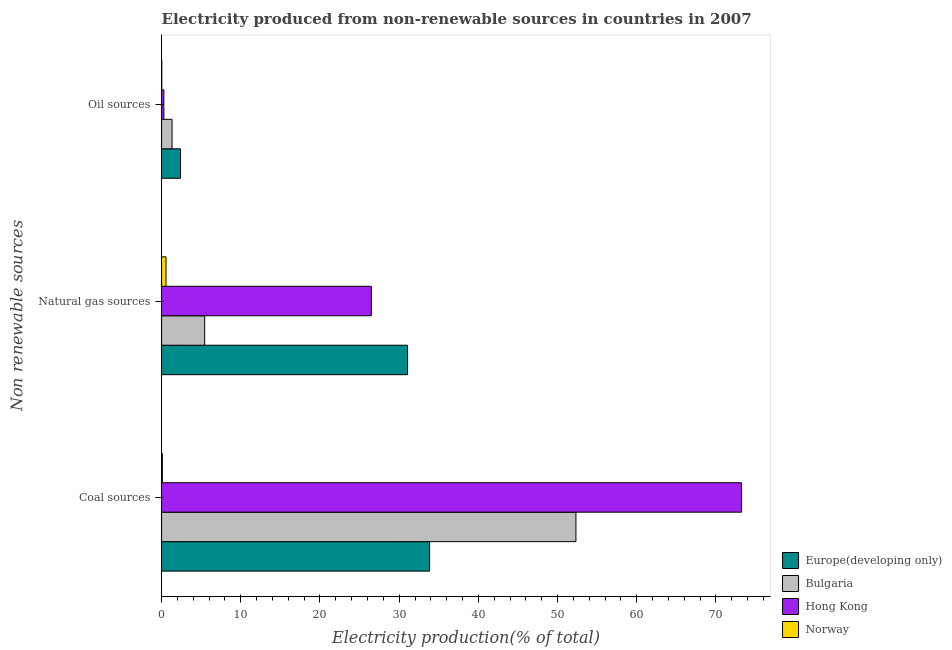Are the number of bars on each tick of the Y-axis equal?
Your answer should be very brief. Yes. What is the label of the 3rd group of bars from the top?
Your response must be concise. Coal sources. What is the percentage of electricity produced by coal in Hong Kong?
Provide a short and direct response. 73.23. Across all countries, what is the maximum percentage of electricity produced by coal?
Provide a short and direct response. 73.23. Across all countries, what is the minimum percentage of electricity produced by oil sources?
Make the answer very short. 0.03. In which country was the percentage of electricity produced by coal maximum?
Offer a terse response. Hong Kong. What is the total percentage of electricity produced by coal in the graph?
Your response must be concise. 159.48. What is the difference between the percentage of electricity produced by coal in Norway and that in Bulgaria?
Make the answer very short. -52.22. What is the difference between the percentage of electricity produced by coal in Europe(developing only) and the percentage of electricity produced by natural gas in Bulgaria?
Offer a terse response. 28.4. What is the average percentage of electricity produced by oil sources per country?
Provide a succinct answer. 1.01. What is the difference between the percentage of electricity produced by coal and percentage of electricity produced by oil sources in Bulgaria?
Offer a terse response. 50.99. In how many countries, is the percentage of electricity produced by oil sources greater than 64 %?
Your answer should be very brief. 0. What is the ratio of the percentage of electricity produced by coal in Norway to that in Bulgaria?
Make the answer very short. 0. Is the percentage of electricity produced by oil sources in Bulgaria less than that in Hong Kong?
Ensure brevity in your answer.  No. What is the difference between the highest and the second highest percentage of electricity produced by coal?
Your response must be concise. 20.91. What is the difference between the highest and the lowest percentage of electricity produced by oil sources?
Offer a very short reply. 2.37. In how many countries, is the percentage of electricity produced by coal greater than the average percentage of electricity produced by coal taken over all countries?
Your answer should be very brief. 2. Is the sum of the percentage of electricity produced by coal in Bulgaria and Norway greater than the maximum percentage of electricity produced by oil sources across all countries?
Keep it short and to the point. Yes. What does the 1st bar from the top in Natural gas sources represents?
Your response must be concise. Norway. What does the 1st bar from the bottom in Coal sources represents?
Keep it short and to the point. Europe(developing only). How many bars are there?
Your response must be concise. 12. What is the difference between two consecutive major ticks on the X-axis?
Your answer should be compact. 10. Are the values on the major ticks of X-axis written in scientific E-notation?
Provide a succinct answer. No. Does the graph contain grids?
Your answer should be compact. No. What is the title of the graph?
Offer a terse response. Electricity produced from non-renewable sources in countries in 2007. What is the label or title of the Y-axis?
Make the answer very short. Non renewable sources. What is the Electricity production(% of total) in Europe(developing only) in Coal sources?
Make the answer very short. 33.84. What is the Electricity production(% of total) in Bulgaria in Coal sources?
Ensure brevity in your answer.  52.32. What is the Electricity production(% of total) in Hong Kong in Coal sources?
Your answer should be very brief. 73.23. What is the Electricity production(% of total) in Norway in Coal sources?
Offer a terse response. 0.1. What is the Electricity production(% of total) of Europe(developing only) in Natural gas sources?
Offer a very short reply. 31.06. What is the Electricity production(% of total) in Bulgaria in Natural gas sources?
Offer a terse response. 5.44. What is the Electricity production(% of total) in Hong Kong in Natural gas sources?
Your response must be concise. 26.48. What is the Electricity production(% of total) of Norway in Natural gas sources?
Your response must be concise. 0.56. What is the Electricity production(% of total) in Europe(developing only) in Oil sources?
Your response must be concise. 2.39. What is the Electricity production(% of total) of Bulgaria in Oil sources?
Offer a very short reply. 1.32. What is the Electricity production(% of total) in Hong Kong in Oil sources?
Give a very brief answer. 0.29. What is the Electricity production(% of total) of Norway in Oil sources?
Keep it short and to the point. 0.03. Across all Non renewable sources, what is the maximum Electricity production(% of total) in Europe(developing only)?
Your answer should be very brief. 33.84. Across all Non renewable sources, what is the maximum Electricity production(% of total) in Bulgaria?
Provide a succinct answer. 52.32. Across all Non renewable sources, what is the maximum Electricity production(% of total) of Hong Kong?
Offer a very short reply. 73.23. Across all Non renewable sources, what is the maximum Electricity production(% of total) in Norway?
Keep it short and to the point. 0.56. Across all Non renewable sources, what is the minimum Electricity production(% of total) of Europe(developing only)?
Keep it short and to the point. 2.39. Across all Non renewable sources, what is the minimum Electricity production(% of total) of Bulgaria?
Offer a very short reply. 1.32. Across all Non renewable sources, what is the minimum Electricity production(% of total) in Hong Kong?
Offer a terse response. 0.29. Across all Non renewable sources, what is the minimum Electricity production(% of total) of Norway?
Provide a succinct answer. 0.03. What is the total Electricity production(% of total) of Europe(developing only) in the graph?
Ensure brevity in your answer.  67.29. What is the total Electricity production(% of total) of Bulgaria in the graph?
Give a very brief answer. 59.08. What is the total Electricity production(% of total) of Hong Kong in the graph?
Keep it short and to the point. 100. What is the total Electricity production(% of total) in Norway in the graph?
Your answer should be very brief. 0.69. What is the difference between the Electricity production(% of total) in Europe(developing only) in Coal sources and that in Natural gas sources?
Your response must be concise. 2.78. What is the difference between the Electricity production(% of total) in Bulgaria in Coal sources and that in Natural gas sources?
Ensure brevity in your answer.  46.88. What is the difference between the Electricity production(% of total) in Hong Kong in Coal sources and that in Natural gas sources?
Provide a short and direct response. 46.74. What is the difference between the Electricity production(% of total) in Norway in Coal sources and that in Natural gas sources?
Provide a succinct answer. -0.46. What is the difference between the Electricity production(% of total) in Europe(developing only) in Coal sources and that in Oil sources?
Your response must be concise. 31.45. What is the difference between the Electricity production(% of total) in Bulgaria in Coal sources and that in Oil sources?
Offer a very short reply. 50.99. What is the difference between the Electricity production(% of total) in Hong Kong in Coal sources and that in Oil sources?
Make the answer very short. 72.94. What is the difference between the Electricity production(% of total) in Norway in Coal sources and that in Oil sources?
Your answer should be compact. 0.07. What is the difference between the Electricity production(% of total) of Europe(developing only) in Natural gas sources and that in Oil sources?
Provide a short and direct response. 28.67. What is the difference between the Electricity production(% of total) of Bulgaria in Natural gas sources and that in Oil sources?
Offer a very short reply. 4.12. What is the difference between the Electricity production(% of total) of Hong Kong in Natural gas sources and that in Oil sources?
Provide a succinct answer. 26.2. What is the difference between the Electricity production(% of total) in Norway in Natural gas sources and that in Oil sources?
Your answer should be very brief. 0.54. What is the difference between the Electricity production(% of total) of Europe(developing only) in Coal sources and the Electricity production(% of total) of Bulgaria in Natural gas sources?
Your answer should be compact. 28.4. What is the difference between the Electricity production(% of total) in Europe(developing only) in Coal sources and the Electricity production(% of total) in Hong Kong in Natural gas sources?
Keep it short and to the point. 7.36. What is the difference between the Electricity production(% of total) of Europe(developing only) in Coal sources and the Electricity production(% of total) of Norway in Natural gas sources?
Your answer should be very brief. 33.28. What is the difference between the Electricity production(% of total) in Bulgaria in Coal sources and the Electricity production(% of total) in Hong Kong in Natural gas sources?
Provide a short and direct response. 25.83. What is the difference between the Electricity production(% of total) of Bulgaria in Coal sources and the Electricity production(% of total) of Norway in Natural gas sources?
Offer a terse response. 51.75. What is the difference between the Electricity production(% of total) of Hong Kong in Coal sources and the Electricity production(% of total) of Norway in Natural gas sources?
Your answer should be very brief. 72.66. What is the difference between the Electricity production(% of total) in Europe(developing only) in Coal sources and the Electricity production(% of total) in Bulgaria in Oil sources?
Make the answer very short. 32.52. What is the difference between the Electricity production(% of total) of Europe(developing only) in Coal sources and the Electricity production(% of total) of Hong Kong in Oil sources?
Offer a terse response. 33.55. What is the difference between the Electricity production(% of total) in Europe(developing only) in Coal sources and the Electricity production(% of total) in Norway in Oil sources?
Your answer should be compact. 33.82. What is the difference between the Electricity production(% of total) of Bulgaria in Coal sources and the Electricity production(% of total) of Hong Kong in Oil sources?
Give a very brief answer. 52.03. What is the difference between the Electricity production(% of total) in Bulgaria in Coal sources and the Electricity production(% of total) in Norway in Oil sources?
Offer a terse response. 52.29. What is the difference between the Electricity production(% of total) in Hong Kong in Coal sources and the Electricity production(% of total) in Norway in Oil sources?
Your answer should be compact. 73.2. What is the difference between the Electricity production(% of total) in Europe(developing only) in Natural gas sources and the Electricity production(% of total) in Bulgaria in Oil sources?
Your answer should be very brief. 29.74. What is the difference between the Electricity production(% of total) in Europe(developing only) in Natural gas sources and the Electricity production(% of total) in Hong Kong in Oil sources?
Offer a terse response. 30.77. What is the difference between the Electricity production(% of total) of Europe(developing only) in Natural gas sources and the Electricity production(% of total) of Norway in Oil sources?
Provide a short and direct response. 31.04. What is the difference between the Electricity production(% of total) in Bulgaria in Natural gas sources and the Electricity production(% of total) in Hong Kong in Oil sources?
Offer a very short reply. 5.15. What is the difference between the Electricity production(% of total) of Bulgaria in Natural gas sources and the Electricity production(% of total) of Norway in Oil sources?
Offer a terse response. 5.41. What is the difference between the Electricity production(% of total) of Hong Kong in Natural gas sources and the Electricity production(% of total) of Norway in Oil sources?
Give a very brief answer. 26.46. What is the average Electricity production(% of total) in Europe(developing only) per Non renewable sources?
Give a very brief answer. 22.43. What is the average Electricity production(% of total) of Bulgaria per Non renewable sources?
Make the answer very short. 19.69. What is the average Electricity production(% of total) of Hong Kong per Non renewable sources?
Keep it short and to the point. 33.33. What is the average Electricity production(% of total) in Norway per Non renewable sources?
Your answer should be very brief. 0.23. What is the difference between the Electricity production(% of total) in Europe(developing only) and Electricity production(% of total) in Bulgaria in Coal sources?
Give a very brief answer. -18.47. What is the difference between the Electricity production(% of total) in Europe(developing only) and Electricity production(% of total) in Hong Kong in Coal sources?
Ensure brevity in your answer.  -39.38. What is the difference between the Electricity production(% of total) in Europe(developing only) and Electricity production(% of total) in Norway in Coal sources?
Ensure brevity in your answer.  33.74. What is the difference between the Electricity production(% of total) of Bulgaria and Electricity production(% of total) of Hong Kong in Coal sources?
Keep it short and to the point. -20.91. What is the difference between the Electricity production(% of total) in Bulgaria and Electricity production(% of total) in Norway in Coal sources?
Your answer should be compact. 52.22. What is the difference between the Electricity production(% of total) in Hong Kong and Electricity production(% of total) in Norway in Coal sources?
Offer a terse response. 73.13. What is the difference between the Electricity production(% of total) of Europe(developing only) and Electricity production(% of total) of Bulgaria in Natural gas sources?
Make the answer very short. 25.62. What is the difference between the Electricity production(% of total) in Europe(developing only) and Electricity production(% of total) in Hong Kong in Natural gas sources?
Provide a succinct answer. 4.58. What is the difference between the Electricity production(% of total) of Europe(developing only) and Electricity production(% of total) of Norway in Natural gas sources?
Ensure brevity in your answer.  30.5. What is the difference between the Electricity production(% of total) in Bulgaria and Electricity production(% of total) in Hong Kong in Natural gas sources?
Offer a terse response. -21.04. What is the difference between the Electricity production(% of total) of Bulgaria and Electricity production(% of total) of Norway in Natural gas sources?
Your answer should be compact. 4.88. What is the difference between the Electricity production(% of total) of Hong Kong and Electricity production(% of total) of Norway in Natural gas sources?
Your response must be concise. 25.92. What is the difference between the Electricity production(% of total) of Europe(developing only) and Electricity production(% of total) of Bulgaria in Oil sources?
Your answer should be very brief. 1.07. What is the difference between the Electricity production(% of total) in Europe(developing only) and Electricity production(% of total) in Hong Kong in Oil sources?
Your answer should be very brief. 2.1. What is the difference between the Electricity production(% of total) of Europe(developing only) and Electricity production(% of total) of Norway in Oil sources?
Provide a short and direct response. 2.37. What is the difference between the Electricity production(% of total) in Bulgaria and Electricity production(% of total) in Hong Kong in Oil sources?
Provide a short and direct response. 1.04. What is the difference between the Electricity production(% of total) in Bulgaria and Electricity production(% of total) in Norway in Oil sources?
Give a very brief answer. 1.3. What is the difference between the Electricity production(% of total) of Hong Kong and Electricity production(% of total) of Norway in Oil sources?
Keep it short and to the point. 0.26. What is the ratio of the Electricity production(% of total) in Europe(developing only) in Coal sources to that in Natural gas sources?
Your response must be concise. 1.09. What is the ratio of the Electricity production(% of total) of Bulgaria in Coal sources to that in Natural gas sources?
Provide a succinct answer. 9.62. What is the ratio of the Electricity production(% of total) in Hong Kong in Coal sources to that in Natural gas sources?
Provide a short and direct response. 2.76. What is the ratio of the Electricity production(% of total) in Norway in Coal sources to that in Natural gas sources?
Provide a short and direct response. 0.18. What is the ratio of the Electricity production(% of total) in Europe(developing only) in Coal sources to that in Oil sources?
Offer a very short reply. 14.15. What is the ratio of the Electricity production(% of total) in Bulgaria in Coal sources to that in Oil sources?
Your response must be concise. 39.55. What is the ratio of the Electricity production(% of total) in Hong Kong in Coal sources to that in Oil sources?
Offer a very short reply. 254.67. What is the ratio of the Electricity production(% of total) of Norway in Coal sources to that in Oil sources?
Ensure brevity in your answer.  3.91. What is the ratio of the Electricity production(% of total) of Europe(developing only) in Natural gas sources to that in Oil sources?
Offer a terse response. 12.99. What is the ratio of the Electricity production(% of total) in Bulgaria in Natural gas sources to that in Oil sources?
Your answer should be compact. 4.11. What is the ratio of the Electricity production(% of total) of Hong Kong in Natural gas sources to that in Oil sources?
Your response must be concise. 92.11. What is the ratio of the Electricity production(% of total) in Norway in Natural gas sources to that in Oil sources?
Give a very brief answer. 21.83. What is the difference between the highest and the second highest Electricity production(% of total) in Europe(developing only)?
Offer a very short reply. 2.78. What is the difference between the highest and the second highest Electricity production(% of total) of Bulgaria?
Your answer should be compact. 46.88. What is the difference between the highest and the second highest Electricity production(% of total) in Hong Kong?
Your answer should be compact. 46.74. What is the difference between the highest and the second highest Electricity production(% of total) in Norway?
Make the answer very short. 0.46. What is the difference between the highest and the lowest Electricity production(% of total) in Europe(developing only)?
Provide a succinct answer. 31.45. What is the difference between the highest and the lowest Electricity production(% of total) in Bulgaria?
Keep it short and to the point. 50.99. What is the difference between the highest and the lowest Electricity production(% of total) of Hong Kong?
Make the answer very short. 72.94. What is the difference between the highest and the lowest Electricity production(% of total) of Norway?
Ensure brevity in your answer.  0.54. 